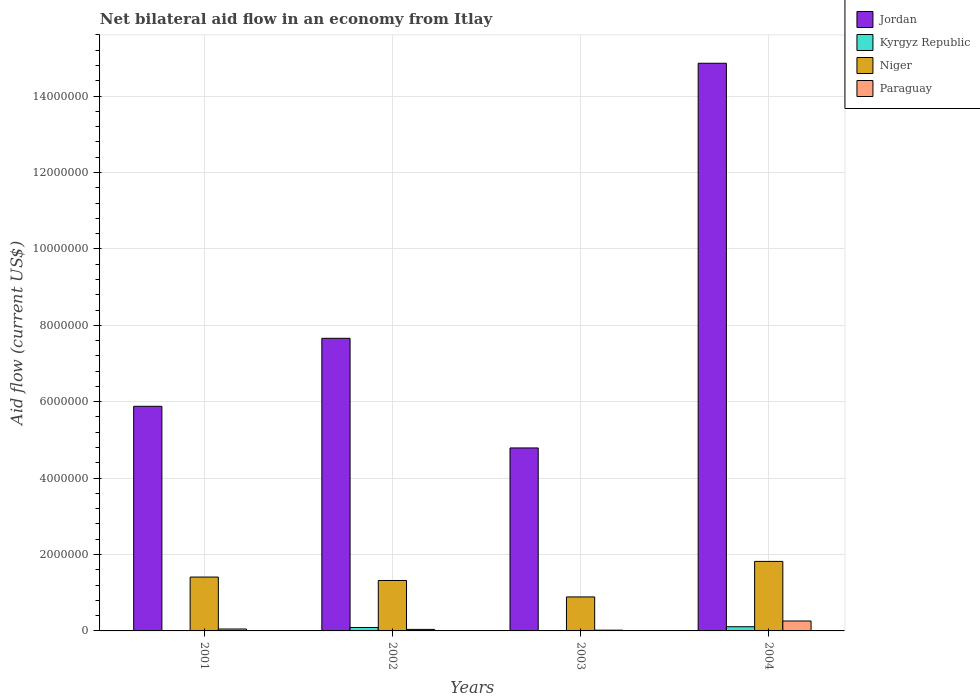How many different coloured bars are there?
Ensure brevity in your answer.  4. Are the number of bars on each tick of the X-axis equal?
Offer a very short reply. Yes. How many bars are there on the 1st tick from the left?
Provide a succinct answer. 4. How many bars are there on the 3rd tick from the right?
Give a very brief answer. 4. In how many cases, is the number of bars for a given year not equal to the number of legend labels?
Make the answer very short. 0. Across all years, what is the maximum net bilateral aid flow in Paraguay?
Provide a short and direct response. 2.60e+05. In which year was the net bilateral aid flow in Paraguay maximum?
Ensure brevity in your answer.  2004. In which year was the net bilateral aid flow in Paraguay minimum?
Keep it short and to the point. 2003. What is the total net bilateral aid flow in Niger in the graph?
Keep it short and to the point. 5.44e+06. What is the difference between the net bilateral aid flow in Kyrgyz Republic in 2001 and that in 2004?
Provide a succinct answer. -1.00e+05. What is the difference between the net bilateral aid flow in Jordan in 2001 and the net bilateral aid flow in Kyrgyz Republic in 2004?
Provide a succinct answer. 5.77e+06. What is the average net bilateral aid flow in Paraguay per year?
Your answer should be very brief. 9.25e+04. In the year 2003, what is the difference between the net bilateral aid flow in Jordan and net bilateral aid flow in Paraguay?
Offer a very short reply. 4.77e+06. What is the ratio of the net bilateral aid flow in Jordan in 2001 to that in 2002?
Provide a succinct answer. 0.77. Is the net bilateral aid flow in Niger in 2002 less than that in 2003?
Provide a succinct answer. No. Is the difference between the net bilateral aid flow in Jordan in 2001 and 2003 greater than the difference between the net bilateral aid flow in Paraguay in 2001 and 2003?
Your response must be concise. Yes. What is the difference between the highest and the lowest net bilateral aid flow in Niger?
Provide a short and direct response. 9.30e+05. In how many years, is the net bilateral aid flow in Jordan greater than the average net bilateral aid flow in Jordan taken over all years?
Keep it short and to the point. 1. Is the sum of the net bilateral aid flow in Paraguay in 2002 and 2003 greater than the maximum net bilateral aid flow in Niger across all years?
Ensure brevity in your answer.  No. Is it the case that in every year, the sum of the net bilateral aid flow in Jordan and net bilateral aid flow in Paraguay is greater than the sum of net bilateral aid flow in Niger and net bilateral aid flow in Kyrgyz Republic?
Ensure brevity in your answer.  Yes. What does the 3rd bar from the left in 2002 represents?
Ensure brevity in your answer.  Niger. What does the 4th bar from the right in 2001 represents?
Your answer should be very brief. Jordan. Are the values on the major ticks of Y-axis written in scientific E-notation?
Your response must be concise. No. Does the graph contain any zero values?
Offer a very short reply. No. Where does the legend appear in the graph?
Ensure brevity in your answer.  Top right. How many legend labels are there?
Provide a short and direct response. 4. What is the title of the graph?
Provide a succinct answer. Net bilateral aid flow in an economy from Itlay. What is the label or title of the X-axis?
Give a very brief answer. Years. What is the label or title of the Y-axis?
Offer a very short reply. Aid flow (current US$). What is the Aid flow (current US$) in Jordan in 2001?
Your answer should be very brief. 5.88e+06. What is the Aid flow (current US$) in Niger in 2001?
Make the answer very short. 1.41e+06. What is the Aid flow (current US$) of Paraguay in 2001?
Make the answer very short. 5.00e+04. What is the Aid flow (current US$) in Jordan in 2002?
Your answer should be very brief. 7.66e+06. What is the Aid flow (current US$) of Kyrgyz Republic in 2002?
Your answer should be compact. 9.00e+04. What is the Aid flow (current US$) of Niger in 2002?
Your response must be concise. 1.32e+06. What is the Aid flow (current US$) in Paraguay in 2002?
Your response must be concise. 4.00e+04. What is the Aid flow (current US$) of Jordan in 2003?
Make the answer very short. 4.79e+06. What is the Aid flow (current US$) in Niger in 2003?
Your response must be concise. 8.90e+05. What is the Aid flow (current US$) in Jordan in 2004?
Your answer should be very brief. 1.49e+07. What is the Aid flow (current US$) in Niger in 2004?
Make the answer very short. 1.82e+06. Across all years, what is the maximum Aid flow (current US$) of Jordan?
Offer a terse response. 1.49e+07. Across all years, what is the maximum Aid flow (current US$) of Kyrgyz Republic?
Ensure brevity in your answer.  1.10e+05. Across all years, what is the maximum Aid flow (current US$) in Niger?
Give a very brief answer. 1.82e+06. Across all years, what is the maximum Aid flow (current US$) of Paraguay?
Offer a terse response. 2.60e+05. Across all years, what is the minimum Aid flow (current US$) of Jordan?
Provide a succinct answer. 4.79e+06. Across all years, what is the minimum Aid flow (current US$) in Kyrgyz Republic?
Your answer should be compact. 10000. Across all years, what is the minimum Aid flow (current US$) in Niger?
Ensure brevity in your answer.  8.90e+05. What is the total Aid flow (current US$) in Jordan in the graph?
Give a very brief answer. 3.32e+07. What is the total Aid flow (current US$) in Niger in the graph?
Your answer should be compact. 5.44e+06. What is the difference between the Aid flow (current US$) of Jordan in 2001 and that in 2002?
Your answer should be very brief. -1.78e+06. What is the difference between the Aid flow (current US$) of Paraguay in 2001 and that in 2002?
Your answer should be compact. 10000. What is the difference between the Aid flow (current US$) in Jordan in 2001 and that in 2003?
Make the answer very short. 1.09e+06. What is the difference between the Aid flow (current US$) of Kyrgyz Republic in 2001 and that in 2003?
Ensure brevity in your answer.  0. What is the difference between the Aid flow (current US$) of Niger in 2001 and that in 2003?
Give a very brief answer. 5.20e+05. What is the difference between the Aid flow (current US$) of Jordan in 2001 and that in 2004?
Offer a very short reply. -8.98e+06. What is the difference between the Aid flow (current US$) in Niger in 2001 and that in 2004?
Your answer should be very brief. -4.10e+05. What is the difference between the Aid flow (current US$) in Paraguay in 2001 and that in 2004?
Give a very brief answer. -2.10e+05. What is the difference between the Aid flow (current US$) in Jordan in 2002 and that in 2003?
Provide a succinct answer. 2.87e+06. What is the difference between the Aid flow (current US$) in Kyrgyz Republic in 2002 and that in 2003?
Keep it short and to the point. 8.00e+04. What is the difference between the Aid flow (current US$) of Jordan in 2002 and that in 2004?
Your answer should be very brief. -7.20e+06. What is the difference between the Aid flow (current US$) in Niger in 2002 and that in 2004?
Make the answer very short. -5.00e+05. What is the difference between the Aid flow (current US$) of Paraguay in 2002 and that in 2004?
Ensure brevity in your answer.  -2.20e+05. What is the difference between the Aid flow (current US$) in Jordan in 2003 and that in 2004?
Offer a very short reply. -1.01e+07. What is the difference between the Aid flow (current US$) of Niger in 2003 and that in 2004?
Your answer should be very brief. -9.30e+05. What is the difference between the Aid flow (current US$) in Jordan in 2001 and the Aid flow (current US$) in Kyrgyz Republic in 2002?
Your answer should be compact. 5.79e+06. What is the difference between the Aid flow (current US$) in Jordan in 2001 and the Aid flow (current US$) in Niger in 2002?
Keep it short and to the point. 4.56e+06. What is the difference between the Aid flow (current US$) of Jordan in 2001 and the Aid flow (current US$) of Paraguay in 2002?
Your response must be concise. 5.84e+06. What is the difference between the Aid flow (current US$) of Kyrgyz Republic in 2001 and the Aid flow (current US$) of Niger in 2002?
Keep it short and to the point. -1.31e+06. What is the difference between the Aid flow (current US$) of Kyrgyz Republic in 2001 and the Aid flow (current US$) of Paraguay in 2002?
Your response must be concise. -3.00e+04. What is the difference between the Aid flow (current US$) of Niger in 2001 and the Aid flow (current US$) of Paraguay in 2002?
Offer a terse response. 1.37e+06. What is the difference between the Aid flow (current US$) of Jordan in 2001 and the Aid flow (current US$) of Kyrgyz Republic in 2003?
Your answer should be very brief. 5.87e+06. What is the difference between the Aid flow (current US$) in Jordan in 2001 and the Aid flow (current US$) in Niger in 2003?
Keep it short and to the point. 4.99e+06. What is the difference between the Aid flow (current US$) in Jordan in 2001 and the Aid flow (current US$) in Paraguay in 2003?
Ensure brevity in your answer.  5.86e+06. What is the difference between the Aid flow (current US$) of Kyrgyz Republic in 2001 and the Aid flow (current US$) of Niger in 2003?
Offer a terse response. -8.80e+05. What is the difference between the Aid flow (current US$) of Kyrgyz Republic in 2001 and the Aid flow (current US$) of Paraguay in 2003?
Your response must be concise. -10000. What is the difference between the Aid flow (current US$) of Niger in 2001 and the Aid flow (current US$) of Paraguay in 2003?
Provide a short and direct response. 1.39e+06. What is the difference between the Aid flow (current US$) of Jordan in 2001 and the Aid flow (current US$) of Kyrgyz Republic in 2004?
Provide a succinct answer. 5.77e+06. What is the difference between the Aid flow (current US$) in Jordan in 2001 and the Aid flow (current US$) in Niger in 2004?
Offer a very short reply. 4.06e+06. What is the difference between the Aid flow (current US$) of Jordan in 2001 and the Aid flow (current US$) of Paraguay in 2004?
Ensure brevity in your answer.  5.62e+06. What is the difference between the Aid flow (current US$) in Kyrgyz Republic in 2001 and the Aid flow (current US$) in Niger in 2004?
Offer a terse response. -1.81e+06. What is the difference between the Aid flow (current US$) in Niger in 2001 and the Aid flow (current US$) in Paraguay in 2004?
Offer a very short reply. 1.15e+06. What is the difference between the Aid flow (current US$) of Jordan in 2002 and the Aid flow (current US$) of Kyrgyz Republic in 2003?
Provide a succinct answer. 7.65e+06. What is the difference between the Aid flow (current US$) in Jordan in 2002 and the Aid flow (current US$) in Niger in 2003?
Keep it short and to the point. 6.77e+06. What is the difference between the Aid flow (current US$) of Jordan in 2002 and the Aid flow (current US$) of Paraguay in 2003?
Ensure brevity in your answer.  7.64e+06. What is the difference between the Aid flow (current US$) of Kyrgyz Republic in 2002 and the Aid flow (current US$) of Niger in 2003?
Your answer should be compact. -8.00e+05. What is the difference between the Aid flow (current US$) in Niger in 2002 and the Aid flow (current US$) in Paraguay in 2003?
Give a very brief answer. 1.30e+06. What is the difference between the Aid flow (current US$) in Jordan in 2002 and the Aid flow (current US$) in Kyrgyz Republic in 2004?
Keep it short and to the point. 7.55e+06. What is the difference between the Aid flow (current US$) of Jordan in 2002 and the Aid flow (current US$) of Niger in 2004?
Offer a very short reply. 5.84e+06. What is the difference between the Aid flow (current US$) in Jordan in 2002 and the Aid flow (current US$) in Paraguay in 2004?
Provide a short and direct response. 7.40e+06. What is the difference between the Aid flow (current US$) in Kyrgyz Republic in 2002 and the Aid flow (current US$) in Niger in 2004?
Your response must be concise. -1.73e+06. What is the difference between the Aid flow (current US$) of Kyrgyz Republic in 2002 and the Aid flow (current US$) of Paraguay in 2004?
Your response must be concise. -1.70e+05. What is the difference between the Aid flow (current US$) in Niger in 2002 and the Aid flow (current US$) in Paraguay in 2004?
Give a very brief answer. 1.06e+06. What is the difference between the Aid flow (current US$) in Jordan in 2003 and the Aid flow (current US$) in Kyrgyz Republic in 2004?
Offer a terse response. 4.68e+06. What is the difference between the Aid flow (current US$) of Jordan in 2003 and the Aid flow (current US$) of Niger in 2004?
Provide a succinct answer. 2.97e+06. What is the difference between the Aid flow (current US$) in Jordan in 2003 and the Aid flow (current US$) in Paraguay in 2004?
Provide a short and direct response. 4.53e+06. What is the difference between the Aid flow (current US$) of Kyrgyz Republic in 2003 and the Aid flow (current US$) of Niger in 2004?
Offer a very short reply. -1.81e+06. What is the difference between the Aid flow (current US$) in Kyrgyz Republic in 2003 and the Aid flow (current US$) in Paraguay in 2004?
Your answer should be very brief. -2.50e+05. What is the difference between the Aid flow (current US$) in Niger in 2003 and the Aid flow (current US$) in Paraguay in 2004?
Your answer should be very brief. 6.30e+05. What is the average Aid flow (current US$) in Jordan per year?
Make the answer very short. 8.30e+06. What is the average Aid flow (current US$) of Kyrgyz Republic per year?
Your answer should be compact. 5.50e+04. What is the average Aid flow (current US$) in Niger per year?
Offer a terse response. 1.36e+06. What is the average Aid flow (current US$) of Paraguay per year?
Offer a very short reply. 9.25e+04. In the year 2001, what is the difference between the Aid flow (current US$) in Jordan and Aid flow (current US$) in Kyrgyz Republic?
Your answer should be very brief. 5.87e+06. In the year 2001, what is the difference between the Aid flow (current US$) in Jordan and Aid flow (current US$) in Niger?
Keep it short and to the point. 4.47e+06. In the year 2001, what is the difference between the Aid flow (current US$) of Jordan and Aid flow (current US$) of Paraguay?
Offer a terse response. 5.83e+06. In the year 2001, what is the difference between the Aid flow (current US$) of Kyrgyz Republic and Aid flow (current US$) of Niger?
Make the answer very short. -1.40e+06. In the year 2001, what is the difference between the Aid flow (current US$) in Niger and Aid flow (current US$) in Paraguay?
Provide a short and direct response. 1.36e+06. In the year 2002, what is the difference between the Aid flow (current US$) in Jordan and Aid flow (current US$) in Kyrgyz Republic?
Provide a succinct answer. 7.57e+06. In the year 2002, what is the difference between the Aid flow (current US$) of Jordan and Aid flow (current US$) of Niger?
Provide a succinct answer. 6.34e+06. In the year 2002, what is the difference between the Aid flow (current US$) of Jordan and Aid flow (current US$) of Paraguay?
Your answer should be very brief. 7.62e+06. In the year 2002, what is the difference between the Aid flow (current US$) of Kyrgyz Republic and Aid flow (current US$) of Niger?
Give a very brief answer. -1.23e+06. In the year 2002, what is the difference between the Aid flow (current US$) in Kyrgyz Republic and Aid flow (current US$) in Paraguay?
Provide a succinct answer. 5.00e+04. In the year 2002, what is the difference between the Aid flow (current US$) of Niger and Aid flow (current US$) of Paraguay?
Your response must be concise. 1.28e+06. In the year 2003, what is the difference between the Aid flow (current US$) in Jordan and Aid flow (current US$) in Kyrgyz Republic?
Ensure brevity in your answer.  4.78e+06. In the year 2003, what is the difference between the Aid flow (current US$) of Jordan and Aid flow (current US$) of Niger?
Ensure brevity in your answer.  3.90e+06. In the year 2003, what is the difference between the Aid flow (current US$) of Jordan and Aid flow (current US$) of Paraguay?
Give a very brief answer. 4.77e+06. In the year 2003, what is the difference between the Aid flow (current US$) in Kyrgyz Republic and Aid flow (current US$) in Niger?
Offer a terse response. -8.80e+05. In the year 2003, what is the difference between the Aid flow (current US$) of Kyrgyz Republic and Aid flow (current US$) of Paraguay?
Your answer should be very brief. -10000. In the year 2003, what is the difference between the Aid flow (current US$) of Niger and Aid flow (current US$) of Paraguay?
Offer a terse response. 8.70e+05. In the year 2004, what is the difference between the Aid flow (current US$) in Jordan and Aid flow (current US$) in Kyrgyz Republic?
Give a very brief answer. 1.48e+07. In the year 2004, what is the difference between the Aid flow (current US$) in Jordan and Aid flow (current US$) in Niger?
Provide a short and direct response. 1.30e+07. In the year 2004, what is the difference between the Aid flow (current US$) in Jordan and Aid flow (current US$) in Paraguay?
Offer a very short reply. 1.46e+07. In the year 2004, what is the difference between the Aid flow (current US$) in Kyrgyz Republic and Aid flow (current US$) in Niger?
Your answer should be very brief. -1.71e+06. In the year 2004, what is the difference between the Aid flow (current US$) of Niger and Aid flow (current US$) of Paraguay?
Provide a succinct answer. 1.56e+06. What is the ratio of the Aid flow (current US$) in Jordan in 2001 to that in 2002?
Your response must be concise. 0.77. What is the ratio of the Aid flow (current US$) in Kyrgyz Republic in 2001 to that in 2002?
Offer a very short reply. 0.11. What is the ratio of the Aid flow (current US$) of Niger in 2001 to that in 2002?
Ensure brevity in your answer.  1.07. What is the ratio of the Aid flow (current US$) of Paraguay in 2001 to that in 2002?
Make the answer very short. 1.25. What is the ratio of the Aid flow (current US$) in Jordan in 2001 to that in 2003?
Provide a short and direct response. 1.23. What is the ratio of the Aid flow (current US$) in Kyrgyz Republic in 2001 to that in 2003?
Give a very brief answer. 1. What is the ratio of the Aid flow (current US$) of Niger in 2001 to that in 2003?
Make the answer very short. 1.58. What is the ratio of the Aid flow (current US$) of Jordan in 2001 to that in 2004?
Your answer should be compact. 0.4. What is the ratio of the Aid flow (current US$) of Kyrgyz Republic in 2001 to that in 2004?
Provide a short and direct response. 0.09. What is the ratio of the Aid flow (current US$) of Niger in 2001 to that in 2004?
Keep it short and to the point. 0.77. What is the ratio of the Aid flow (current US$) in Paraguay in 2001 to that in 2004?
Your answer should be very brief. 0.19. What is the ratio of the Aid flow (current US$) of Jordan in 2002 to that in 2003?
Provide a short and direct response. 1.6. What is the ratio of the Aid flow (current US$) of Kyrgyz Republic in 2002 to that in 2003?
Ensure brevity in your answer.  9. What is the ratio of the Aid flow (current US$) of Niger in 2002 to that in 2003?
Your answer should be very brief. 1.48. What is the ratio of the Aid flow (current US$) in Paraguay in 2002 to that in 2003?
Your answer should be very brief. 2. What is the ratio of the Aid flow (current US$) of Jordan in 2002 to that in 2004?
Ensure brevity in your answer.  0.52. What is the ratio of the Aid flow (current US$) of Kyrgyz Republic in 2002 to that in 2004?
Give a very brief answer. 0.82. What is the ratio of the Aid flow (current US$) in Niger in 2002 to that in 2004?
Give a very brief answer. 0.73. What is the ratio of the Aid flow (current US$) in Paraguay in 2002 to that in 2004?
Make the answer very short. 0.15. What is the ratio of the Aid flow (current US$) in Jordan in 2003 to that in 2004?
Offer a very short reply. 0.32. What is the ratio of the Aid flow (current US$) in Kyrgyz Republic in 2003 to that in 2004?
Keep it short and to the point. 0.09. What is the ratio of the Aid flow (current US$) in Niger in 2003 to that in 2004?
Ensure brevity in your answer.  0.49. What is the ratio of the Aid flow (current US$) in Paraguay in 2003 to that in 2004?
Keep it short and to the point. 0.08. What is the difference between the highest and the second highest Aid flow (current US$) of Jordan?
Your answer should be very brief. 7.20e+06. What is the difference between the highest and the second highest Aid flow (current US$) in Kyrgyz Republic?
Offer a terse response. 2.00e+04. What is the difference between the highest and the second highest Aid flow (current US$) of Paraguay?
Make the answer very short. 2.10e+05. What is the difference between the highest and the lowest Aid flow (current US$) in Jordan?
Your response must be concise. 1.01e+07. What is the difference between the highest and the lowest Aid flow (current US$) in Kyrgyz Republic?
Make the answer very short. 1.00e+05. What is the difference between the highest and the lowest Aid flow (current US$) in Niger?
Offer a terse response. 9.30e+05. What is the difference between the highest and the lowest Aid flow (current US$) of Paraguay?
Make the answer very short. 2.40e+05. 